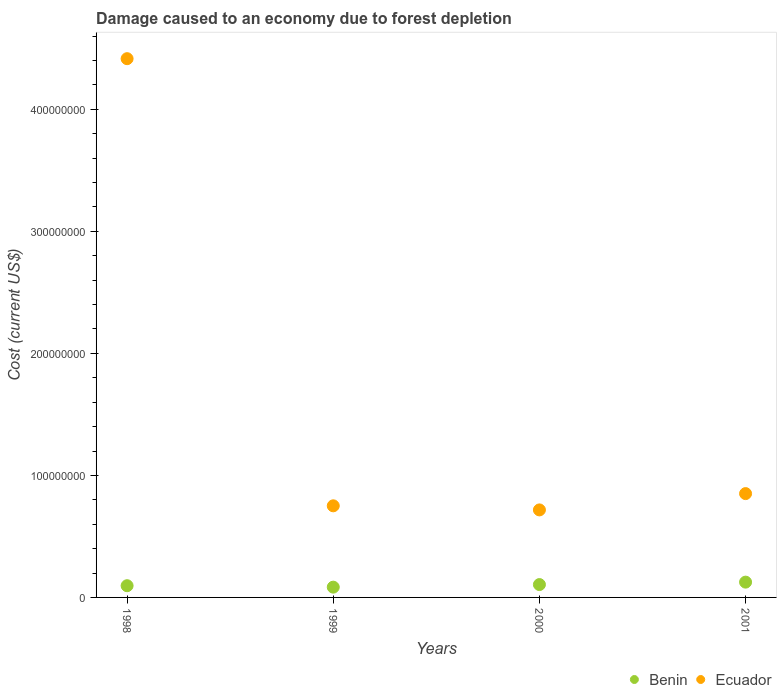What is the cost of damage caused due to forest depletion in Ecuador in 1998?
Ensure brevity in your answer.  4.42e+08. Across all years, what is the maximum cost of damage caused due to forest depletion in Ecuador?
Ensure brevity in your answer.  4.42e+08. Across all years, what is the minimum cost of damage caused due to forest depletion in Ecuador?
Make the answer very short. 7.17e+07. In which year was the cost of damage caused due to forest depletion in Benin minimum?
Give a very brief answer. 1999. What is the total cost of damage caused due to forest depletion in Benin in the graph?
Provide a short and direct response. 4.11e+07. What is the difference between the cost of damage caused due to forest depletion in Ecuador in 1998 and that in 2001?
Your answer should be very brief. 3.56e+08. What is the difference between the cost of damage caused due to forest depletion in Ecuador in 1998 and the cost of damage caused due to forest depletion in Benin in 2000?
Provide a succinct answer. 4.31e+08. What is the average cost of damage caused due to forest depletion in Benin per year?
Provide a succinct answer. 1.03e+07. In the year 1998, what is the difference between the cost of damage caused due to forest depletion in Ecuador and cost of damage caused due to forest depletion in Benin?
Offer a very short reply. 4.32e+08. What is the ratio of the cost of damage caused due to forest depletion in Benin in 1999 to that in 2000?
Your answer should be very brief. 0.8. What is the difference between the highest and the second highest cost of damage caused due to forest depletion in Benin?
Give a very brief answer. 2.00e+06. What is the difference between the highest and the lowest cost of damage caused due to forest depletion in Ecuador?
Give a very brief answer. 3.70e+08. In how many years, is the cost of damage caused due to forest depletion in Benin greater than the average cost of damage caused due to forest depletion in Benin taken over all years?
Ensure brevity in your answer.  2. Is the cost of damage caused due to forest depletion in Benin strictly greater than the cost of damage caused due to forest depletion in Ecuador over the years?
Make the answer very short. No. How many dotlines are there?
Keep it short and to the point. 2. Are the values on the major ticks of Y-axis written in scientific E-notation?
Give a very brief answer. No. What is the title of the graph?
Your answer should be compact. Damage caused to an economy due to forest depletion. Does "Kenya" appear as one of the legend labels in the graph?
Your answer should be compact. No. What is the label or title of the X-axis?
Your response must be concise. Years. What is the label or title of the Y-axis?
Give a very brief answer. Cost (current US$). What is the Cost (current US$) of Benin in 1998?
Your response must be concise. 9.60e+06. What is the Cost (current US$) in Ecuador in 1998?
Your answer should be compact. 4.42e+08. What is the Cost (current US$) in Benin in 1999?
Offer a very short reply. 8.42e+06. What is the Cost (current US$) of Ecuador in 1999?
Keep it short and to the point. 7.51e+07. What is the Cost (current US$) of Benin in 2000?
Your answer should be very brief. 1.05e+07. What is the Cost (current US$) of Ecuador in 2000?
Offer a terse response. 7.17e+07. What is the Cost (current US$) in Benin in 2001?
Provide a short and direct response. 1.25e+07. What is the Cost (current US$) of Ecuador in 2001?
Keep it short and to the point. 8.51e+07. Across all years, what is the maximum Cost (current US$) in Benin?
Provide a succinct answer. 1.25e+07. Across all years, what is the maximum Cost (current US$) in Ecuador?
Your answer should be very brief. 4.42e+08. Across all years, what is the minimum Cost (current US$) of Benin?
Offer a very short reply. 8.42e+06. Across all years, what is the minimum Cost (current US$) in Ecuador?
Your answer should be very brief. 7.17e+07. What is the total Cost (current US$) in Benin in the graph?
Make the answer very short. 4.11e+07. What is the total Cost (current US$) in Ecuador in the graph?
Ensure brevity in your answer.  6.73e+08. What is the difference between the Cost (current US$) of Benin in 1998 and that in 1999?
Your answer should be very brief. 1.19e+06. What is the difference between the Cost (current US$) of Ecuador in 1998 and that in 1999?
Give a very brief answer. 3.66e+08. What is the difference between the Cost (current US$) in Benin in 1998 and that in 2000?
Your answer should be very brief. -9.32e+05. What is the difference between the Cost (current US$) in Ecuador in 1998 and that in 2000?
Your response must be concise. 3.70e+08. What is the difference between the Cost (current US$) in Benin in 1998 and that in 2001?
Offer a very short reply. -2.93e+06. What is the difference between the Cost (current US$) of Ecuador in 1998 and that in 2001?
Keep it short and to the point. 3.56e+08. What is the difference between the Cost (current US$) of Benin in 1999 and that in 2000?
Keep it short and to the point. -2.12e+06. What is the difference between the Cost (current US$) in Ecuador in 1999 and that in 2000?
Offer a very short reply. 3.36e+06. What is the difference between the Cost (current US$) of Benin in 1999 and that in 2001?
Keep it short and to the point. -4.12e+06. What is the difference between the Cost (current US$) in Ecuador in 1999 and that in 2001?
Your response must be concise. -1.00e+07. What is the difference between the Cost (current US$) of Benin in 2000 and that in 2001?
Your response must be concise. -2.00e+06. What is the difference between the Cost (current US$) of Ecuador in 2000 and that in 2001?
Ensure brevity in your answer.  -1.34e+07. What is the difference between the Cost (current US$) of Benin in 1998 and the Cost (current US$) of Ecuador in 1999?
Your answer should be compact. -6.55e+07. What is the difference between the Cost (current US$) in Benin in 1998 and the Cost (current US$) in Ecuador in 2000?
Make the answer very short. -6.21e+07. What is the difference between the Cost (current US$) of Benin in 1998 and the Cost (current US$) of Ecuador in 2001?
Your answer should be very brief. -7.55e+07. What is the difference between the Cost (current US$) in Benin in 1999 and the Cost (current US$) in Ecuador in 2000?
Offer a very short reply. -6.33e+07. What is the difference between the Cost (current US$) in Benin in 1999 and the Cost (current US$) in Ecuador in 2001?
Provide a short and direct response. -7.67e+07. What is the difference between the Cost (current US$) in Benin in 2000 and the Cost (current US$) in Ecuador in 2001?
Your answer should be compact. -7.46e+07. What is the average Cost (current US$) in Benin per year?
Keep it short and to the point. 1.03e+07. What is the average Cost (current US$) in Ecuador per year?
Your answer should be compact. 1.68e+08. In the year 1998, what is the difference between the Cost (current US$) in Benin and Cost (current US$) in Ecuador?
Make the answer very short. -4.32e+08. In the year 1999, what is the difference between the Cost (current US$) in Benin and Cost (current US$) in Ecuador?
Your answer should be very brief. -6.67e+07. In the year 2000, what is the difference between the Cost (current US$) in Benin and Cost (current US$) in Ecuador?
Your answer should be compact. -6.12e+07. In the year 2001, what is the difference between the Cost (current US$) in Benin and Cost (current US$) in Ecuador?
Your answer should be compact. -7.26e+07. What is the ratio of the Cost (current US$) in Benin in 1998 to that in 1999?
Offer a terse response. 1.14. What is the ratio of the Cost (current US$) of Ecuador in 1998 to that in 1999?
Your answer should be compact. 5.88. What is the ratio of the Cost (current US$) in Benin in 1998 to that in 2000?
Keep it short and to the point. 0.91. What is the ratio of the Cost (current US$) in Ecuador in 1998 to that in 2000?
Your answer should be compact. 6.16. What is the ratio of the Cost (current US$) of Benin in 1998 to that in 2001?
Your response must be concise. 0.77. What is the ratio of the Cost (current US$) of Ecuador in 1998 to that in 2001?
Ensure brevity in your answer.  5.19. What is the ratio of the Cost (current US$) of Benin in 1999 to that in 2000?
Offer a very short reply. 0.8. What is the ratio of the Cost (current US$) of Ecuador in 1999 to that in 2000?
Ensure brevity in your answer.  1.05. What is the ratio of the Cost (current US$) of Benin in 1999 to that in 2001?
Offer a very short reply. 0.67. What is the ratio of the Cost (current US$) in Ecuador in 1999 to that in 2001?
Offer a very short reply. 0.88. What is the ratio of the Cost (current US$) of Benin in 2000 to that in 2001?
Your response must be concise. 0.84. What is the ratio of the Cost (current US$) of Ecuador in 2000 to that in 2001?
Provide a succinct answer. 0.84. What is the difference between the highest and the second highest Cost (current US$) in Benin?
Give a very brief answer. 2.00e+06. What is the difference between the highest and the second highest Cost (current US$) of Ecuador?
Offer a terse response. 3.56e+08. What is the difference between the highest and the lowest Cost (current US$) in Benin?
Your response must be concise. 4.12e+06. What is the difference between the highest and the lowest Cost (current US$) in Ecuador?
Keep it short and to the point. 3.70e+08. 